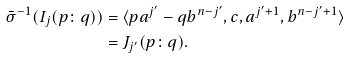<formula> <loc_0><loc_0><loc_500><loc_500>\bar { \sigma } ^ { - 1 } ( I _ { j } ( p \colon q ) ) & = \langle p a ^ { j ^ { \prime } } - q b ^ { n - j ^ { \prime } } , c , a ^ { j ^ { \prime } + 1 } , b ^ { n - j ^ { \prime } + 1 } \rangle \\ & = J _ { j ^ { \prime } } ( p \colon q ) . \\</formula> 